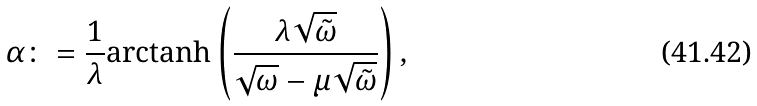<formula> <loc_0><loc_0><loc_500><loc_500>\alpha \colon = \frac { 1 } { \lambda } \text {arctanh} \left ( \frac { \lambda \sqrt { \tilde { \omega } } } { \sqrt { \omega } - \mu \sqrt { \tilde { \omega } } } \right ) ,</formula> 